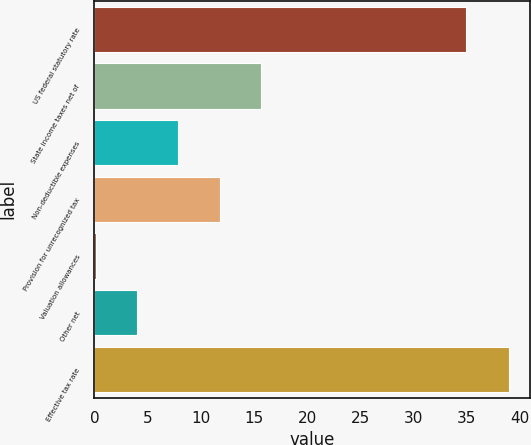Convert chart to OTSL. <chart><loc_0><loc_0><loc_500><loc_500><bar_chart><fcel>US federal statutory rate<fcel>State income taxes net of<fcel>Non-deductible expenses<fcel>Provision for unrecognized tax<fcel>Valuation allowances<fcel>Other net<fcel>Effective tax rate<nl><fcel>35<fcel>15.66<fcel>7.88<fcel>11.77<fcel>0.1<fcel>3.99<fcel>39<nl></chart> 